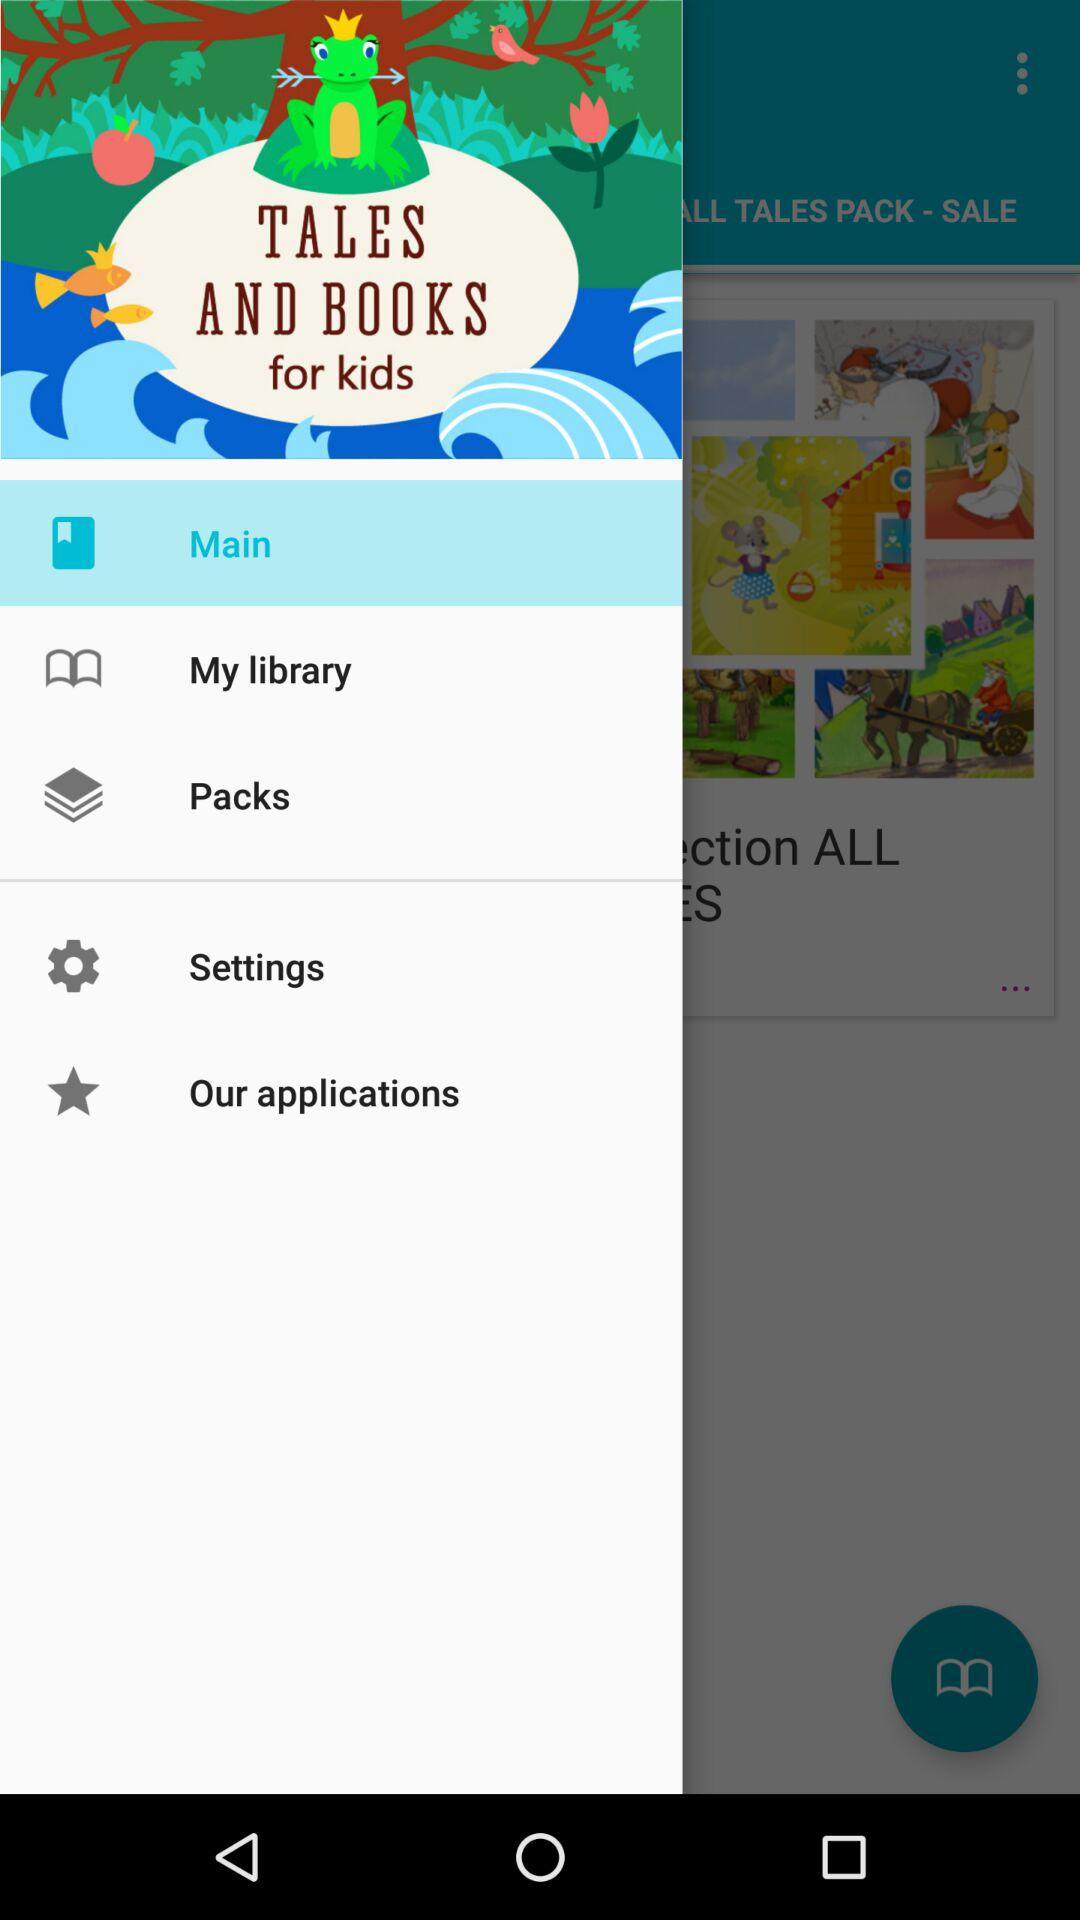What is the selected item? The selected item is "Main". 